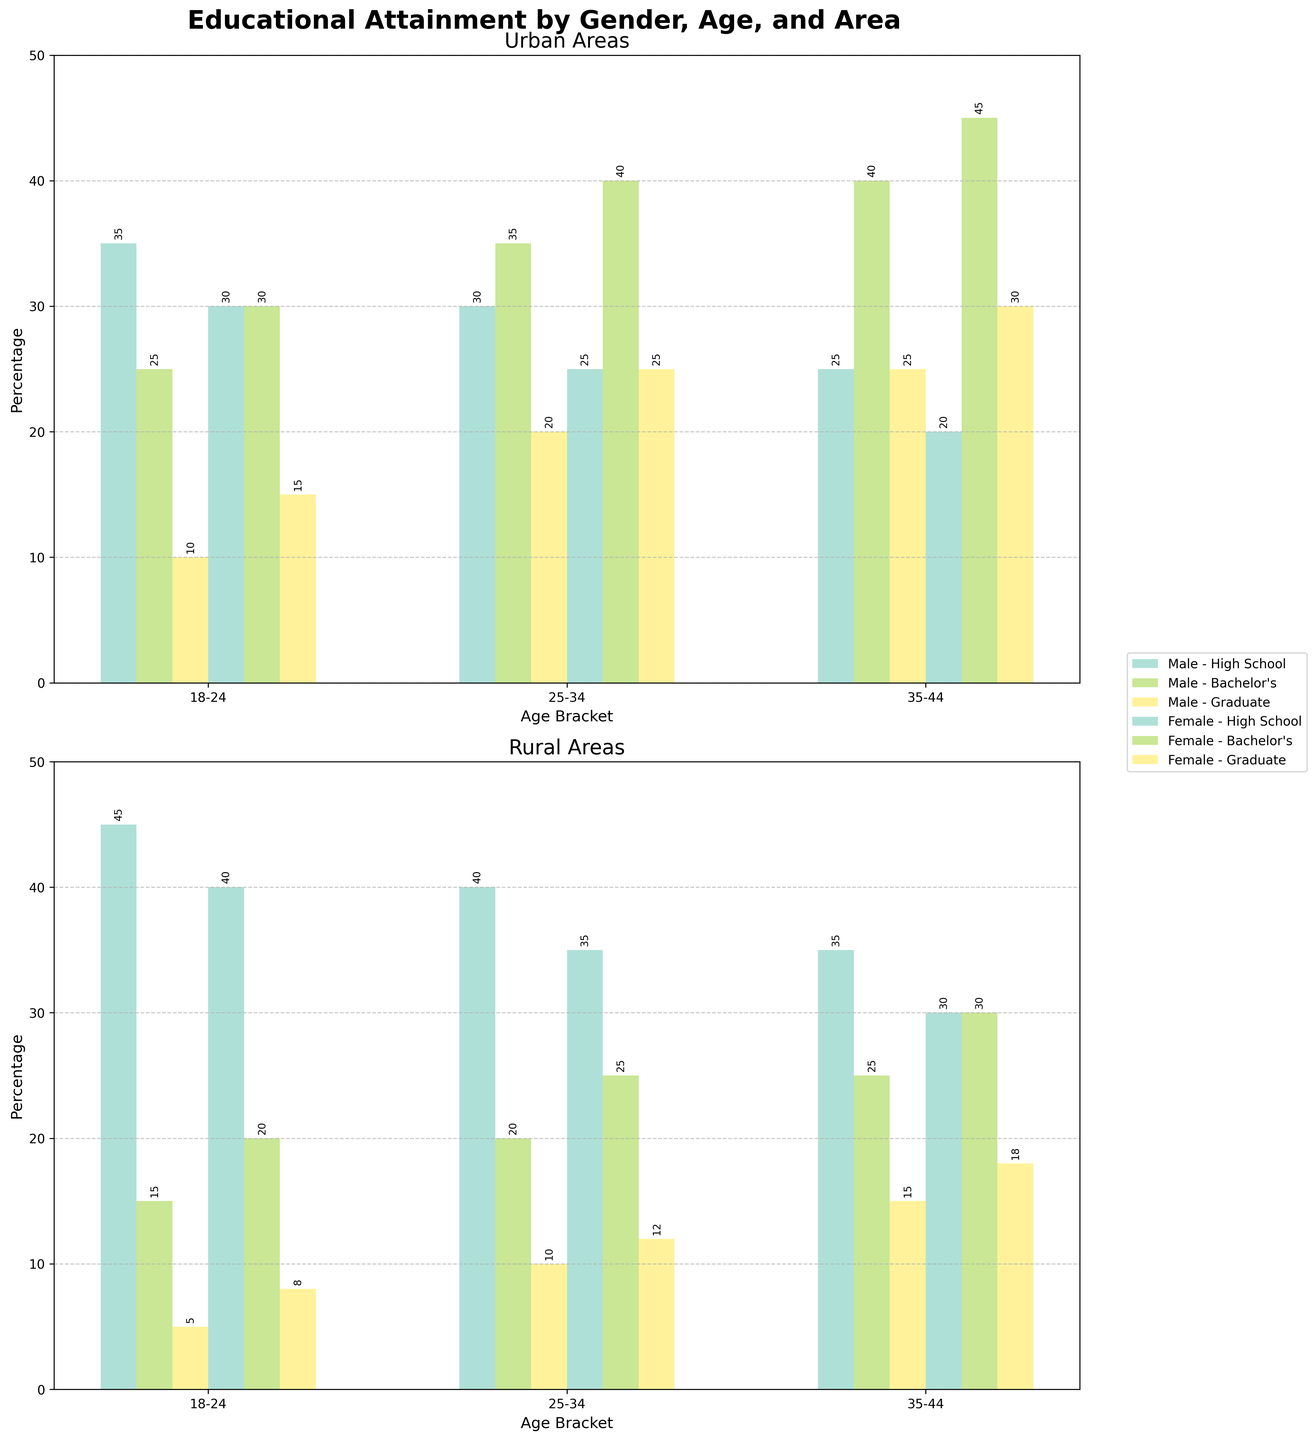Which age bracket in urban areas has the highest percentage of females with Bachelor's degrees? Check the bars labeled 'Female - Bachelor's' in the urban plot. The age bracket with the tallest bar is '35-44', which corresponds to 45%.
Answer: 35-44 What is the sum of the percentages of males with Graduate degrees in rural areas for all age brackets? Identify the bars labeled 'Male - Graduate' in the rural plot. Sum the values for age brackets 18-24 (5), 25-34 (10), and 35-44 (15). 5 + 10 + 15 = 30.
Answer: 30 How does the percentage of females with High School education in the 18-24 age bracket vary between urban and rural areas? Compare the bars labeled 'Female - High School' in the 18-24 age bracket across the urban and rural plots. Urban has 30% and rural has 40%.
Answer: Rural is higher by 10% What percentage of urban males aged 35-44 have a Bachelor's degree, and how does it compare to rural males in the same age bracket? Check the bars labeled 'Male - Bachelor's' for the 35-44 age bracket in both urban and rural plots. Urban is at 40%, and rural is at 25%. Urban is higher by 15%.
Answer: 40%, urban is higher by 15% In which area and gender combination is the percentage of individuals with Graduate degrees the lowest for the 18-24 age bracket? Compare the bars labeled 'Graduate' across all gender and area combinations in the 18-24 age bracket. The lowest bar is 'Rural, Male,' which is 5%.
Answer: Rural, Male If we combined the percentages of females with Bachelor's and Graduate degrees in the 25-34 age bracket in urban areas, what would the total be? Add the percentages of 'Female - Bachelor's' (40%) and 'Female - Graduate' (25%) in urban areas for the 25-34 age bracket. 40 + 25 = 65.
Answer: 65 Which education level shows the largest discrepancy between males and females in urban areas for the 25-34 age bracket? Compare the percentage difference across all education levels for males and females in urban areas for the 25-34 age bracket: High School (30% vs. 25%), Bachelor's (35% vs. 40%), Graduate (20% vs. 25%). The largest difference is for Bachelor's, which is 5%.
Answer: Bachelor's Are there any education levels where the percentage of males is higher than that of females in every age bracket in urban areas? Check if, for each education level (High School, Bachelor's, Graduate), the height of male bars is consistently higher than the female bars across all age brackets in urban plots. None fulfill this criterion.
Answer: No When comparing urban females to rural females in the 35-44 age bracket, which education level has the widest percentage gap? Compare the rural and urban female bars for the 35-44 age bracket across all education levels: High School (20% vs. 30%), Bachelor's (45% vs. 30%), Graduate (30% vs. 18%). Bachelor's has the widest gap of 15%.
Answer: Bachelor's 